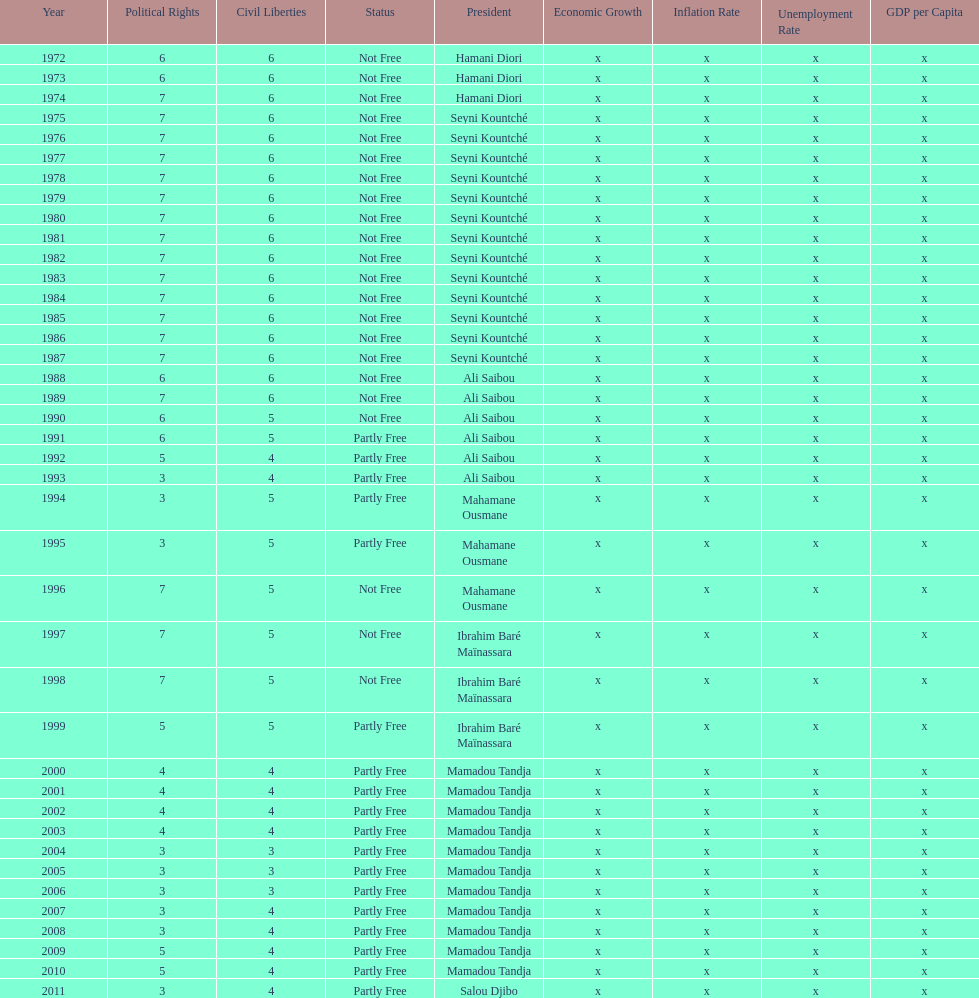How many years was ali saibou president? 6. 